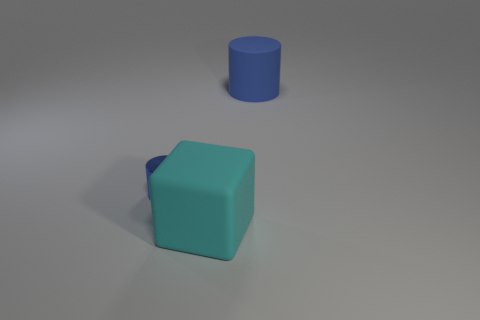Add 3 tiny yellow objects. How many objects exist? 6 Subtract all blocks. How many objects are left? 2 Subtract all red metal cylinders. Subtract all small blue objects. How many objects are left? 2 Add 1 big blue cylinders. How many big blue cylinders are left? 2 Add 1 tiny blue metallic cylinders. How many tiny blue metallic cylinders exist? 2 Subtract 0 red cylinders. How many objects are left? 3 